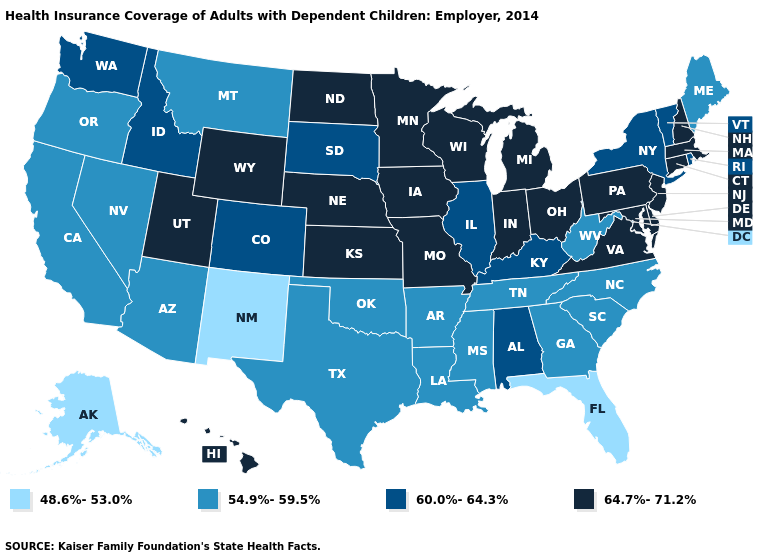Is the legend a continuous bar?
Concise answer only. No. Name the states that have a value in the range 60.0%-64.3%?
Keep it brief. Alabama, Colorado, Idaho, Illinois, Kentucky, New York, Rhode Island, South Dakota, Vermont, Washington. Is the legend a continuous bar?
Short answer required. No. Among the states that border Texas , which have the highest value?
Keep it brief. Arkansas, Louisiana, Oklahoma. Does the first symbol in the legend represent the smallest category?
Keep it brief. Yes. Is the legend a continuous bar?
Concise answer only. No. Name the states that have a value in the range 54.9%-59.5%?
Be succinct. Arizona, Arkansas, California, Georgia, Louisiana, Maine, Mississippi, Montana, Nevada, North Carolina, Oklahoma, Oregon, South Carolina, Tennessee, Texas, West Virginia. Does New York have the lowest value in the USA?
Give a very brief answer. No. What is the value of Rhode Island?
Keep it brief. 60.0%-64.3%. Among the states that border Connecticut , which have the highest value?
Give a very brief answer. Massachusetts. Name the states that have a value in the range 54.9%-59.5%?
Concise answer only. Arizona, Arkansas, California, Georgia, Louisiana, Maine, Mississippi, Montana, Nevada, North Carolina, Oklahoma, Oregon, South Carolina, Tennessee, Texas, West Virginia. Does the map have missing data?
Write a very short answer. No. What is the value of Maryland?
Quick response, please. 64.7%-71.2%. Name the states that have a value in the range 48.6%-53.0%?
Write a very short answer. Alaska, Florida, New Mexico. 